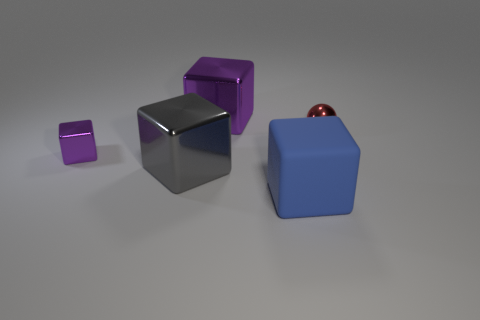What size is the metallic object that is on the right side of the gray shiny block and to the left of the big blue rubber block? The metallic object appears to be relatively small, especially in comparison to the large blue block situated to its right and the medium-sized gray block to its left. It seems to be about the size of a standard marble or small ball. 